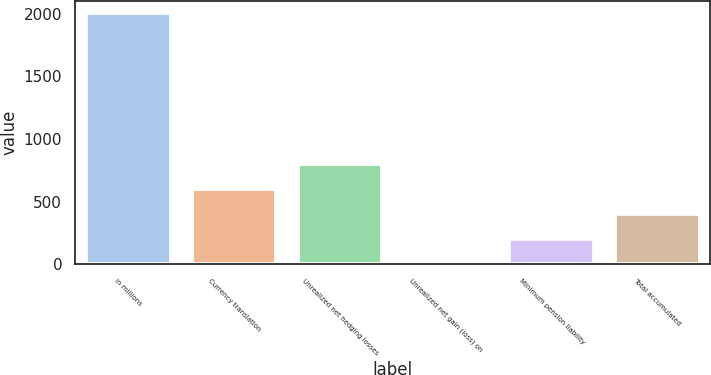<chart> <loc_0><loc_0><loc_500><loc_500><bar_chart><fcel>in millions<fcel>Currency translation<fcel>Unrealized net hedging losses<fcel>Unrealized net gain (loss) on<fcel>Minimum pension liability<fcel>Total accumulated<nl><fcel>2004<fcel>601.9<fcel>802.2<fcel>1<fcel>201.3<fcel>401.6<nl></chart> 